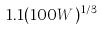<formula> <loc_0><loc_0><loc_500><loc_500>1 . 1 ( 1 0 0 W ) ^ { 1 / 3 }</formula> 